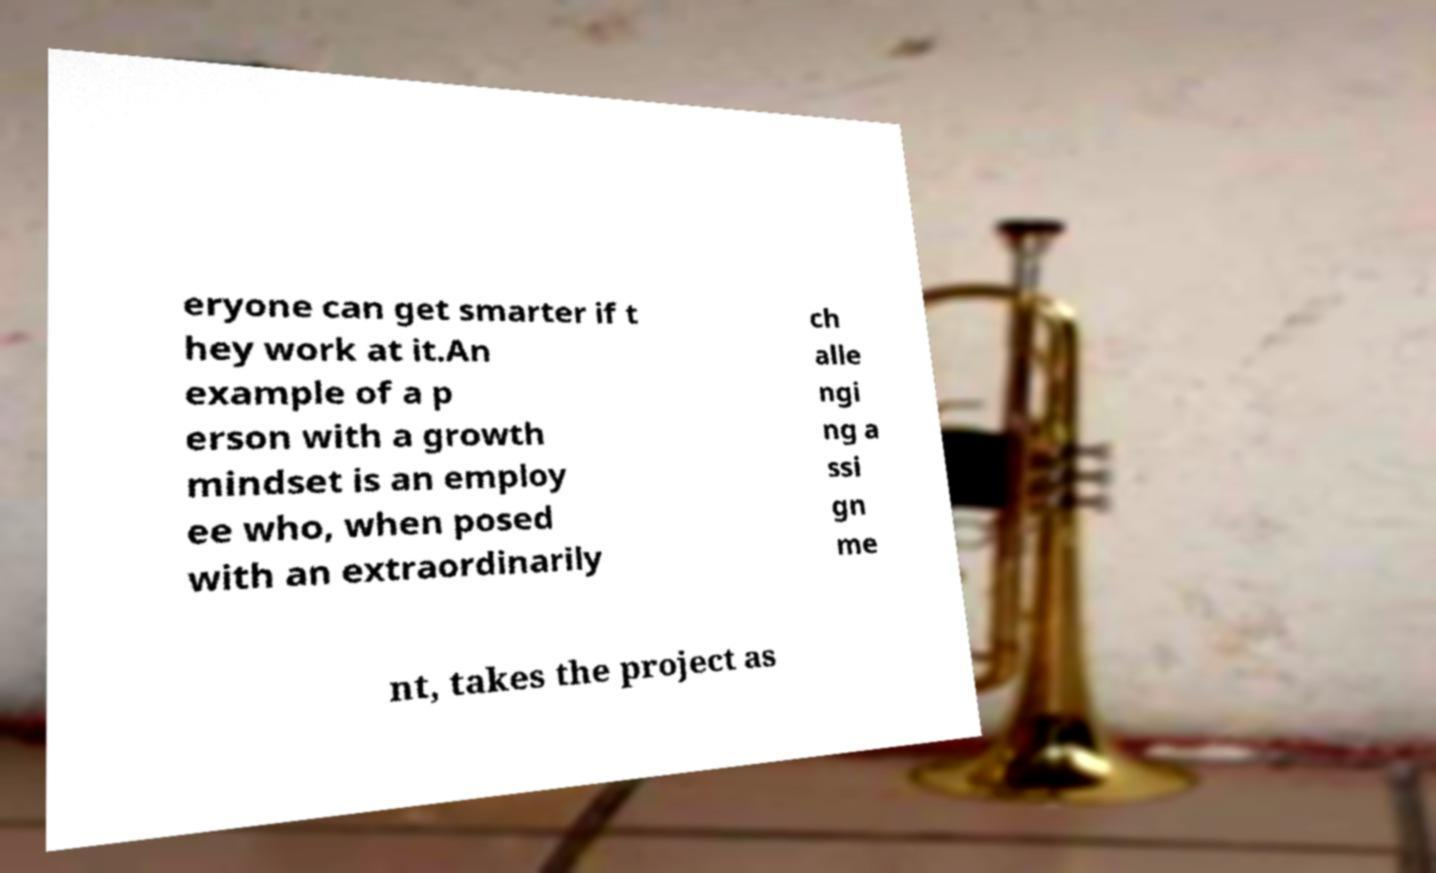Could you extract and type out the text from this image? eryone can get smarter if t hey work at it.An example of a p erson with a growth mindset is an employ ee who, when posed with an extraordinarily ch alle ngi ng a ssi gn me nt, takes the project as 